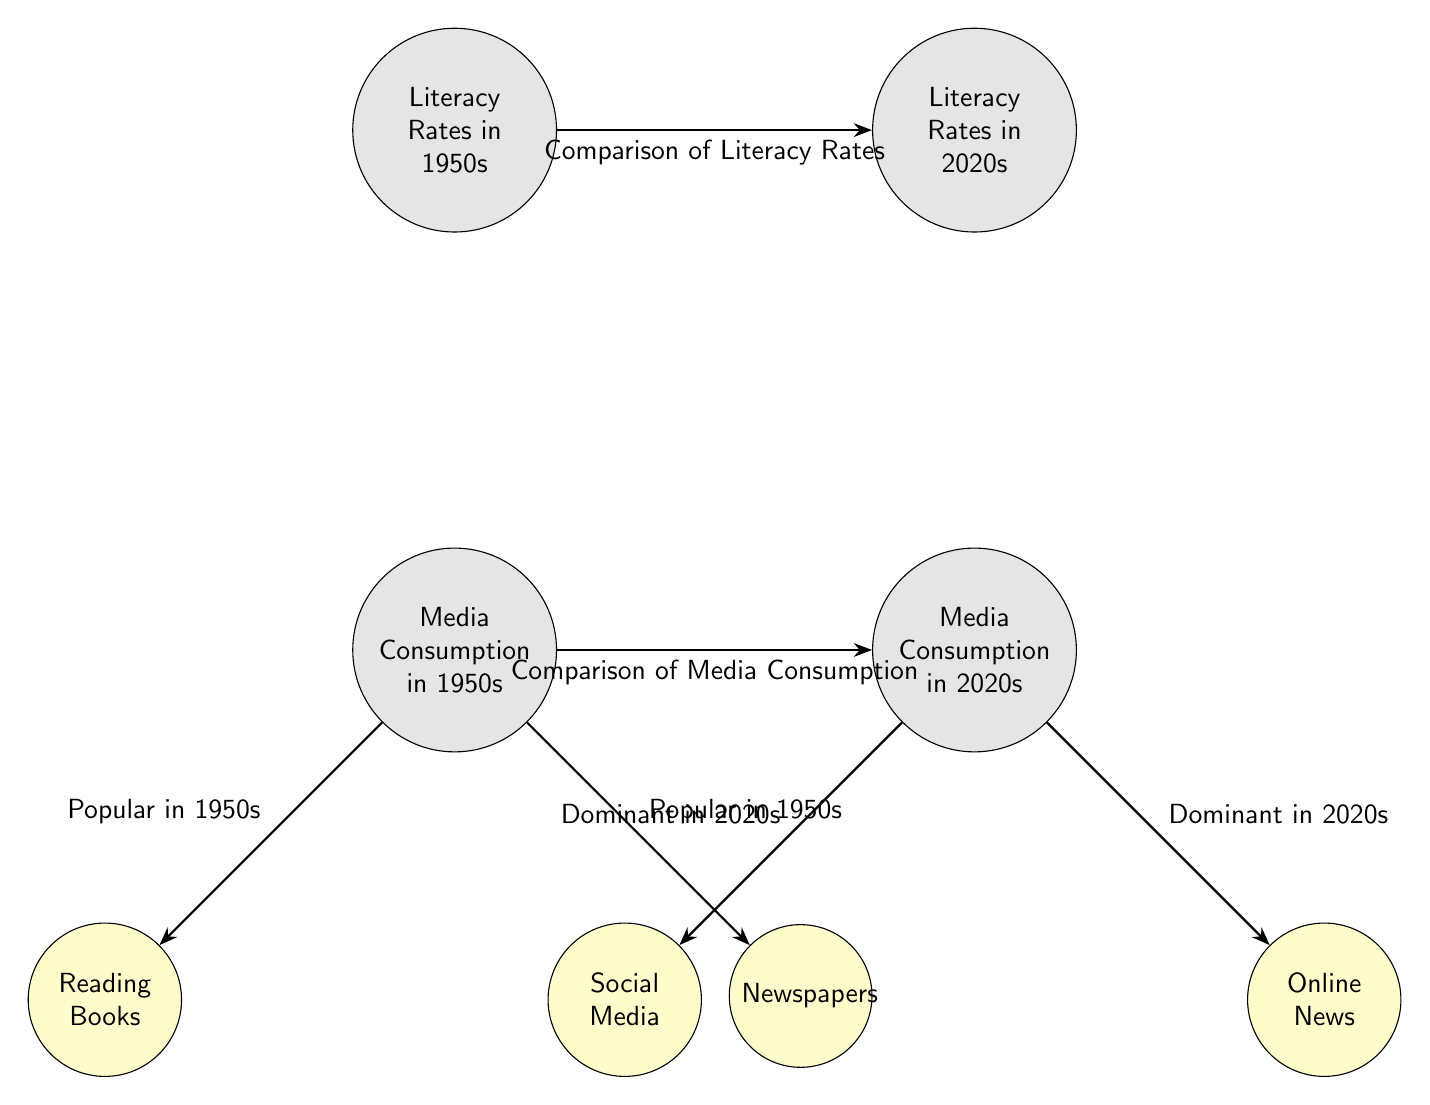What are the two eras of literacy rates compared in the diagram? The diagram includes the literacy rates from two distinct eras: the 1950s and the 2020s, represented as nodes.
Answer: 1950s, 2020s What media types were popular in the 1950s according to the diagram? The diagram specifies two media types popular in the 1950s: Reading Books and Newspapers, each represented as nodes connected to the Media Consumption in 1950s node.
Answer: Reading Books, Newspapers What media types dominate the 2020s according to the diagram? The nodes connected to Media Consumption in 2020s show that the dominant media types are Social Media and Online News, which are directly indicated in the diagram.
Answer: Social Media, Online News How many nodes are there in the diagram? By counting the nodes present, there are a total of six nodes: two for literacy rates, two for media consumption, and two for specific media types.
Answer: 6 What relationship does the arrow from Literacy Rates in 1950s to Literacy Rates in 2020s indicate? The arrow signifies a relationship of comparison between the literacy rates of the two eras, showing a directional flow of information regarding how literacy has changed over time.
Answer: Comparison of Literacy Rates Which media type is labeled as dominant in the 2020s? The diagram associates the label "Dominant in 2020s" with Social Media, indicating its primary status among media types during this era.
Answer: Social Media What is the significance of the arrows in the diagram? The arrows demonstrate the connections and relationships between different nodes, indicating comparisons and dominance of media types across the specified eras, which is vital for understanding the flow of information.
Answer: Indicate relationships Which media type was popular in both the 1950s and 2020s? According to the diagram, there is no media type that appears in both the 1950s and 2020s categories, as they each show distinct media preferences.
Answer: None 